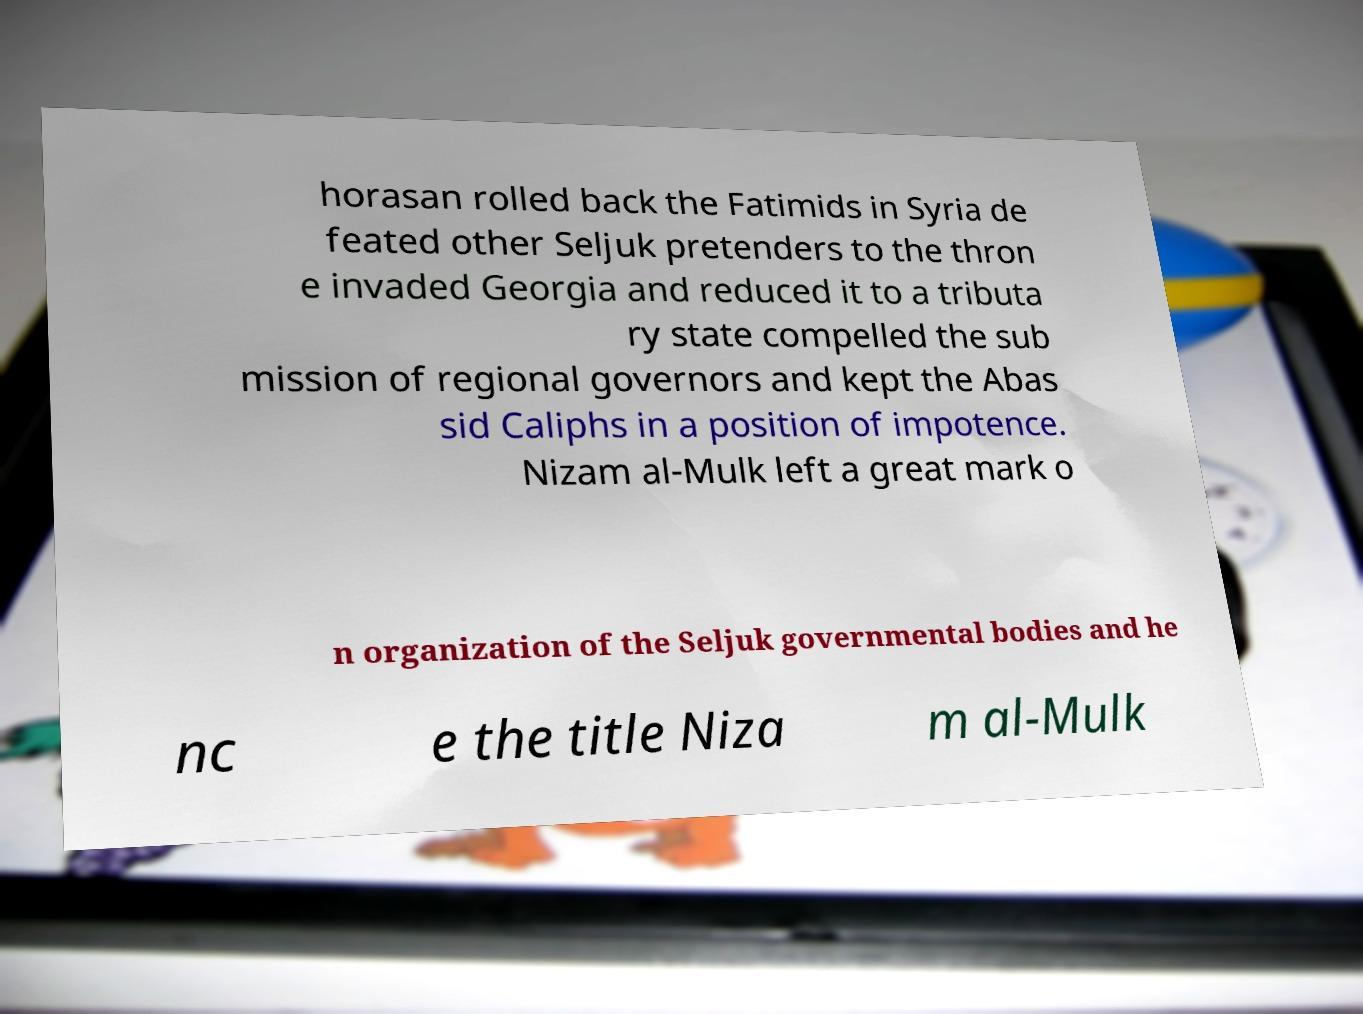Could you assist in decoding the text presented in this image and type it out clearly? horasan rolled back the Fatimids in Syria de feated other Seljuk pretenders to the thron e invaded Georgia and reduced it to a tributa ry state compelled the sub mission of regional governors and kept the Abas sid Caliphs in a position of impotence. Nizam al-Mulk left a great mark o n organization of the Seljuk governmental bodies and he nc e the title Niza m al-Mulk 